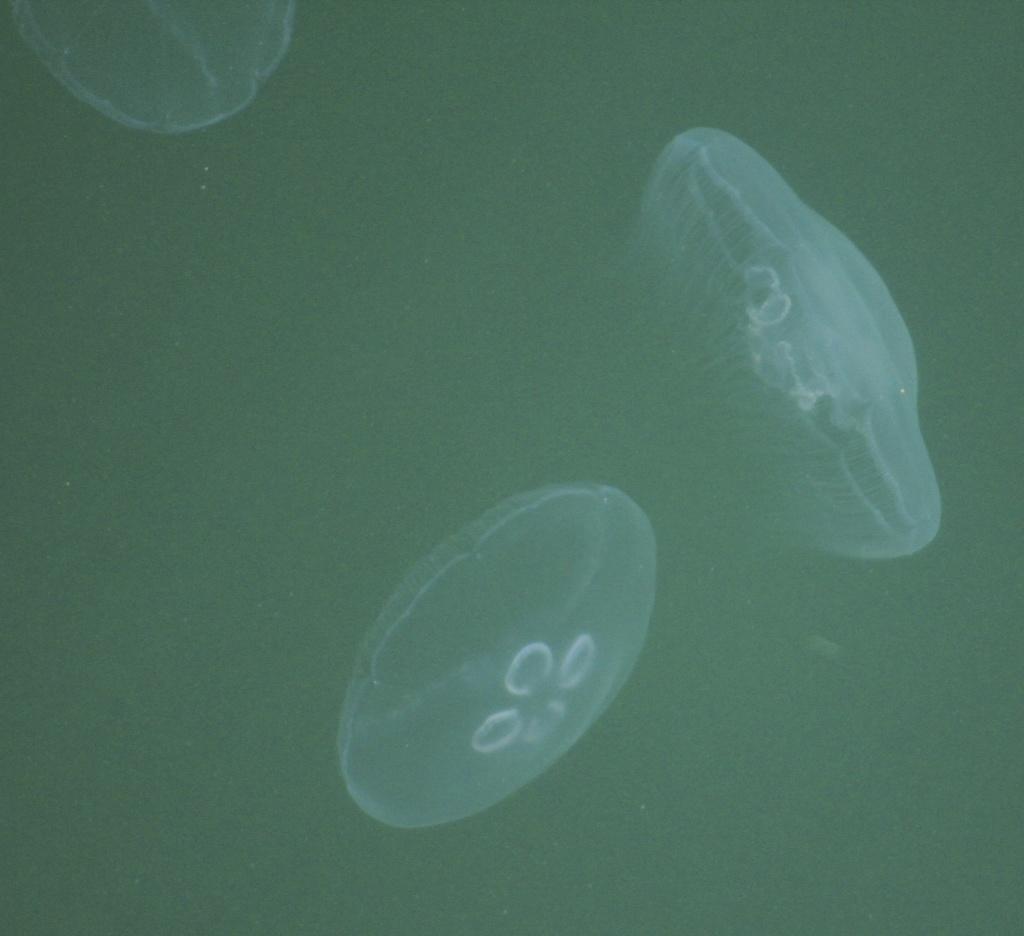Describe this image in one or two sentences. In this picture we can see there are three jellyfish. Behind the jellyfish, there is the dark background. 